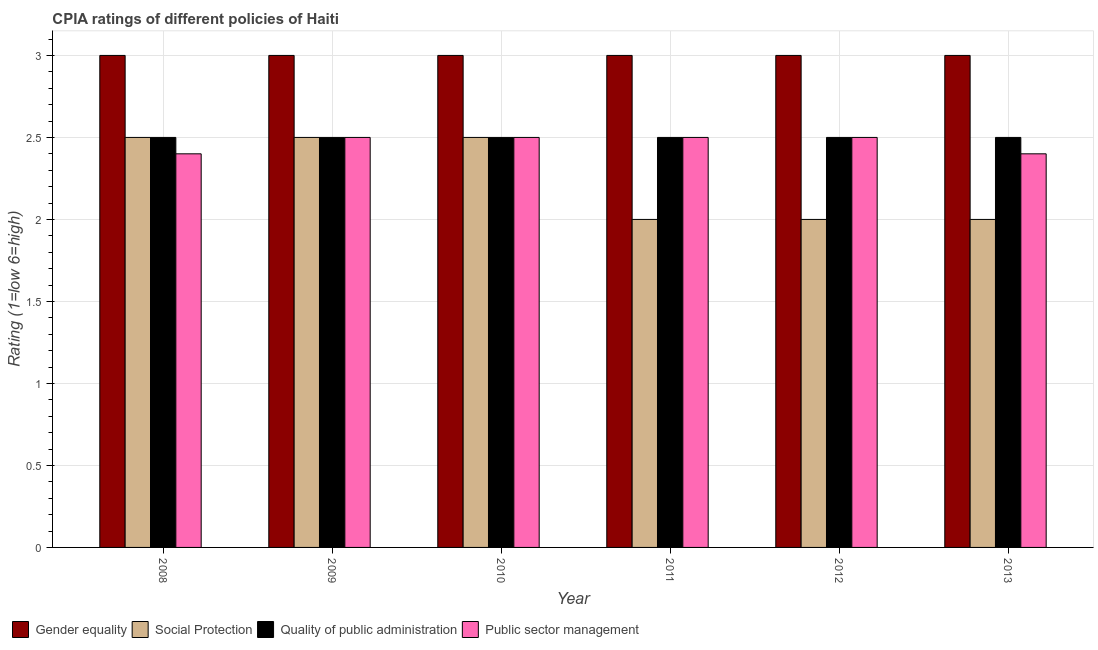Are the number of bars per tick equal to the number of legend labels?
Your response must be concise. Yes. How many bars are there on the 4th tick from the left?
Give a very brief answer. 4. How many bars are there on the 3rd tick from the right?
Offer a very short reply. 4. What is the label of the 5th group of bars from the left?
Make the answer very short. 2012. In how many cases, is the number of bars for a given year not equal to the number of legend labels?
Provide a short and direct response. 0. What is the cpia rating of gender equality in 2008?
Offer a terse response. 3. Across all years, what is the maximum cpia rating of gender equality?
Keep it short and to the point. 3. Across all years, what is the minimum cpia rating of public sector management?
Make the answer very short. 2.4. In which year was the cpia rating of public sector management maximum?
Offer a very short reply. 2009. In which year was the cpia rating of public sector management minimum?
Offer a terse response. 2008. What is the total cpia rating of gender equality in the graph?
Provide a succinct answer. 18. What is the difference between the cpia rating of public sector management in 2011 and that in 2013?
Offer a very short reply. 0.1. What is the average cpia rating of social protection per year?
Provide a short and direct response. 2.25. In the year 2008, what is the difference between the cpia rating of gender equality and cpia rating of social protection?
Offer a very short reply. 0. What is the difference between the highest and the second highest cpia rating of social protection?
Offer a very short reply. 0. What is the difference between the highest and the lowest cpia rating of gender equality?
Your answer should be very brief. 0. In how many years, is the cpia rating of gender equality greater than the average cpia rating of gender equality taken over all years?
Make the answer very short. 0. What does the 3rd bar from the left in 2011 represents?
Your answer should be compact. Quality of public administration. What does the 1st bar from the right in 2011 represents?
Offer a terse response. Public sector management. What is the difference between two consecutive major ticks on the Y-axis?
Keep it short and to the point. 0.5. Does the graph contain any zero values?
Your response must be concise. No. Does the graph contain grids?
Provide a short and direct response. Yes. Where does the legend appear in the graph?
Offer a terse response. Bottom left. How many legend labels are there?
Keep it short and to the point. 4. How are the legend labels stacked?
Make the answer very short. Horizontal. What is the title of the graph?
Your answer should be compact. CPIA ratings of different policies of Haiti. What is the Rating (1=low 6=high) of Gender equality in 2008?
Your answer should be very brief. 3. What is the Rating (1=low 6=high) in Social Protection in 2008?
Provide a succinct answer. 2.5. What is the Rating (1=low 6=high) in Gender equality in 2009?
Offer a terse response. 3. What is the Rating (1=low 6=high) of Gender equality in 2010?
Offer a terse response. 3. What is the Rating (1=low 6=high) of Social Protection in 2010?
Your response must be concise. 2.5. What is the Rating (1=low 6=high) of Quality of public administration in 2010?
Provide a short and direct response. 2.5. What is the Rating (1=low 6=high) of Social Protection in 2011?
Your answer should be very brief. 2. What is the Rating (1=low 6=high) of Public sector management in 2011?
Keep it short and to the point. 2.5. What is the Rating (1=low 6=high) of Gender equality in 2012?
Provide a short and direct response. 3. What is the Rating (1=low 6=high) of Quality of public administration in 2012?
Your answer should be very brief. 2.5. What is the Rating (1=low 6=high) of Public sector management in 2012?
Keep it short and to the point. 2.5. What is the Rating (1=low 6=high) of Gender equality in 2013?
Make the answer very short. 3. What is the Rating (1=low 6=high) in Social Protection in 2013?
Give a very brief answer. 2. What is the Rating (1=low 6=high) in Quality of public administration in 2013?
Provide a succinct answer. 2.5. What is the Rating (1=low 6=high) in Public sector management in 2013?
Provide a short and direct response. 2.4. Across all years, what is the maximum Rating (1=low 6=high) in Social Protection?
Give a very brief answer. 2.5. Across all years, what is the minimum Rating (1=low 6=high) in Social Protection?
Provide a succinct answer. 2. Across all years, what is the minimum Rating (1=low 6=high) of Quality of public administration?
Ensure brevity in your answer.  2.5. Across all years, what is the minimum Rating (1=low 6=high) in Public sector management?
Your response must be concise. 2.4. What is the total Rating (1=low 6=high) in Gender equality in the graph?
Your answer should be compact. 18. What is the total Rating (1=low 6=high) in Quality of public administration in the graph?
Give a very brief answer. 15. What is the difference between the Rating (1=low 6=high) in Gender equality in 2008 and that in 2009?
Keep it short and to the point. 0. What is the difference between the Rating (1=low 6=high) of Quality of public administration in 2008 and that in 2009?
Offer a terse response. 0. What is the difference between the Rating (1=low 6=high) of Public sector management in 2008 and that in 2009?
Provide a succinct answer. -0.1. What is the difference between the Rating (1=low 6=high) in Social Protection in 2008 and that in 2010?
Give a very brief answer. 0. What is the difference between the Rating (1=low 6=high) in Public sector management in 2008 and that in 2010?
Ensure brevity in your answer.  -0.1. What is the difference between the Rating (1=low 6=high) in Gender equality in 2008 and that in 2011?
Offer a terse response. 0. What is the difference between the Rating (1=low 6=high) in Quality of public administration in 2008 and that in 2011?
Give a very brief answer. 0. What is the difference between the Rating (1=low 6=high) of Public sector management in 2008 and that in 2011?
Make the answer very short. -0.1. What is the difference between the Rating (1=low 6=high) in Gender equality in 2008 and that in 2012?
Give a very brief answer. 0. What is the difference between the Rating (1=low 6=high) of Social Protection in 2008 and that in 2012?
Your answer should be compact. 0.5. What is the difference between the Rating (1=low 6=high) in Public sector management in 2008 and that in 2012?
Your answer should be very brief. -0.1. What is the difference between the Rating (1=low 6=high) in Social Protection in 2008 and that in 2013?
Offer a terse response. 0.5. What is the difference between the Rating (1=low 6=high) of Quality of public administration in 2008 and that in 2013?
Keep it short and to the point. 0. What is the difference between the Rating (1=low 6=high) in Public sector management in 2009 and that in 2010?
Provide a succinct answer. 0. What is the difference between the Rating (1=low 6=high) of Gender equality in 2009 and that in 2011?
Your answer should be compact. 0. What is the difference between the Rating (1=low 6=high) in Social Protection in 2009 and that in 2011?
Give a very brief answer. 0.5. What is the difference between the Rating (1=low 6=high) of Quality of public administration in 2009 and that in 2011?
Offer a terse response. 0. What is the difference between the Rating (1=low 6=high) of Public sector management in 2009 and that in 2011?
Keep it short and to the point. 0. What is the difference between the Rating (1=low 6=high) in Gender equality in 2009 and that in 2012?
Provide a succinct answer. 0. What is the difference between the Rating (1=low 6=high) of Social Protection in 2009 and that in 2012?
Your response must be concise. 0.5. What is the difference between the Rating (1=low 6=high) of Public sector management in 2009 and that in 2012?
Make the answer very short. 0. What is the difference between the Rating (1=low 6=high) of Social Protection in 2009 and that in 2013?
Provide a short and direct response. 0.5. What is the difference between the Rating (1=low 6=high) in Public sector management in 2009 and that in 2013?
Provide a succinct answer. 0.1. What is the difference between the Rating (1=low 6=high) in Gender equality in 2010 and that in 2011?
Provide a short and direct response. 0. What is the difference between the Rating (1=low 6=high) of Social Protection in 2010 and that in 2012?
Your answer should be very brief. 0.5. What is the difference between the Rating (1=low 6=high) of Quality of public administration in 2010 and that in 2012?
Keep it short and to the point. 0. What is the difference between the Rating (1=low 6=high) in Public sector management in 2010 and that in 2012?
Offer a very short reply. 0. What is the difference between the Rating (1=low 6=high) of Gender equality in 2010 and that in 2013?
Your answer should be very brief. 0. What is the difference between the Rating (1=low 6=high) of Social Protection in 2010 and that in 2013?
Your response must be concise. 0.5. What is the difference between the Rating (1=low 6=high) in Social Protection in 2011 and that in 2012?
Keep it short and to the point. 0. What is the difference between the Rating (1=low 6=high) of Quality of public administration in 2011 and that in 2012?
Keep it short and to the point. 0. What is the difference between the Rating (1=low 6=high) in Gender equality in 2011 and that in 2013?
Your answer should be compact. 0. What is the difference between the Rating (1=low 6=high) in Social Protection in 2011 and that in 2013?
Make the answer very short. 0. What is the difference between the Rating (1=low 6=high) in Public sector management in 2011 and that in 2013?
Give a very brief answer. 0.1. What is the difference between the Rating (1=low 6=high) of Social Protection in 2012 and that in 2013?
Your answer should be very brief. 0. What is the difference between the Rating (1=low 6=high) of Quality of public administration in 2012 and that in 2013?
Provide a short and direct response. 0. What is the difference between the Rating (1=low 6=high) of Gender equality in 2008 and the Rating (1=low 6=high) of Quality of public administration in 2009?
Your response must be concise. 0.5. What is the difference between the Rating (1=low 6=high) of Gender equality in 2008 and the Rating (1=low 6=high) of Social Protection in 2010?
Offer a very short reply. 0.5. What is the difference between the Rating (1=low 6=high) of Social Protection in 2008 and the Rating (1=low 6=high) of Quality of public administration in 2010?
Make the answer very short. 0. What is the difference between the Rating (1=low 6=high) in Social Protection in 2008 and the Rating (1=low 6=high) in Public sector management in 2011?
Make the answer very short. 0. What is the difference between the Rating (1=low 6=high) in Quality of public administration in 2008 and the Rating (1=low 6=high) in Public sector management in 2011?
Your answer should be compact. 0. What is the difference between the Rating (1=low 6=high) of Gender equality in 2008 and the Rating (1=low 6=high) of Public sector management in 2012?
Your answer should be very brief. 0.5. What is the difference between the Rating (1=low 6=high) in Social Protection in 2008 and the Rating (1=low 6=high) in Quality of public administration in 2012?
Ensure brevity in your answer.  0. What is the difference between the Rating (1=low 6=high) in Social Protection in 2008 and the Rating (1=low 6=high) in Public sector management in 2012?
Ensure brevity in your answer.  0. What is the difference between the Rating (1=low 6=high) of Quality of public administration in 2008 and the Rating (1=low 6=high) of Public sector management in 2012?
Your answer should be compact. 0. What is the difference between the Rating (1=low 6=high) of Gender equality in 2008 and the Rating (1=low 6=high) of Quality of public administration in 2013?
Keep it short and to the point. 0.5. What is the difference between the Rating (1=low 6=high) of Social Protection in 2008 and the Rating (1=low 6=high) of Quality of public administration in 2013?
Make the answer very short. 0. What is the difference between the Rating (1=low 6=high) in Social Protection in 2009 and the Rating (1=low 6=high) in Quality of public administration in 2010?
Make the answer very short. 0. What is the difference between the Rating (1=low 6=high) of Gender equality in 2009 and the Rating (1=low 6=high) of Social Protection in 2011?
Ensure brevity in your answer.  1. What is the difference between the Rating (1=low 6=high) in Gender equality in 2009 and the Rating (1=low 6=high) in Public sector management in 2011?
Provide a short and direct response. 0.5. What is the difference between the Rating (1=low 6=high) of Social Protection in 2009 and the Rating (1=low 6=high) of Quality of public administration in 2011?
Make the answer very short. 0. What is the difference between the Rating (1=low 6=high) of Social Protection in 2009 and the Rating (1=low 6=high) of Public sector management in 2011?
Make the answer very short. 0. What is the difference between the Rating (1=low 6=high) of Gender equality in 2009 and the Rating (1=low 6=high) of Social Protection in 2012?
Your answer should be very brief. 1. What is the difference between the Rating (1=low 6=high) of Social Protection in 2009 and the Rating (1=low 6=high) of Quality of public administration in 2012?
Your response must be concise. 0. What is the difference between the Rating (1=low 6=high) in Social Protection in 2009 and the Rating (1=low 6=high) in Public sector management in 2012?
Keep it short and to the point. 0. What is the difference between the Rating (1=low 6=high) in Quality of public administration in 2009 and the Rating (1=low 6=high) in Public sector management in 2012?
Keep it short and to the point. 0. What is the difference between the Rating (1=low 6=high) of Gender equality in 2009 and the Rating (1=low 6=high) of Social Protection in 2013?
Your answer should be compact. 1. What is the difference between the Rating (1=low 6=high) of Gender equality in 2009 and the Rating (1=low 6=high) of Quality of public administration in 2013?
Provide a succinct answer. 0.5. What is the difference between the Rating (1=low 6=high) in Gender equality in 2009 and the Rating (1=low 6=high) in Public sector management in 2013?
Your answer should be very brief. 0.6. What is the difference between the Rating (1=low 6=high) in Gender equality in 2010 and the Rating (1=low 6=high) in Quality of public administration in 2011?
Give a very brief answer. 0.5. What is the difference between the Rating (1=low 6=high) in Gender equality in 2010 and the Rating (1=low 6=high) in Social Protection in 2012?
Provide a short and direct response. 1. What is the difference between the Rating (1=low 6=high) of Gender equality in 2010 and the Rating (1=low 6=high) of Quality of public administration in 2012?
Offer a terse response. 0.5. What is the difference between the Rating (1=low 6=high) of Gender equality in 2010 and the Rating (1=low 6=high) of Public sector management in 2012?
Make the answer very short. 0.5. What is the difference between the Rating (1=low 6=high) of Social Protection in 2010 and the Rating (1=low 6=high) of Public sector management in 2012?
Give a very brief answer. 0. What is the difference between the Rating (1=low 6=high) in Quality of public administration in 2010 and the Rating (1=low 6=high) in Public sector management in 2012?
Your answer should be compact. 0. What is the difference between the Rating (1=low 6=high) of Gender equality in 2010 and the Rating (1=low 6=high) of Public sector management in 2013?
Your answer should be very brief. 0.6. What is the difference between the Rating (1=low 6=high) of Social Protection in 2010 and the Rating (1=low 6=high) of Public sector management in 2013?
Provide a short and direct response. 0.1. What is the difference between the Rating (1=low 6=high) in Quality of public administration in 2010 and the Rating (1=low 6=high) in Public sector management in 2013?
Your answer should be very brief. 0.1. What is the difference between the Rating (1=low 6=high) in Gender equality in 2011 and the Rating (1=low 6=high) in Public sector management in 2012?
Make the answer very short. 0.5. What is the difference between the Rating (1=low 6=high) of Social Protection in 2011 and the Rating (1=low 6=high) of Quality of public administration in 2012?
Your answer should be very brief. -0.5. What is the difference between the Rating (1=low 6=high) of Gender equality in 2011 and the Rating (1=low 6=high) of Social Protection in 2013?
Your answer should be very brief. 1. What is the difference between the Rating (1=low 6=high) of Gender equality in 2011 and the Rating (1=low 6=high) of Quality of public administration in 2013?
Give a very brief answer. 0.5. What is the difference between the Rating (1=low 6=high) of Gender equality in 2011 and the Rating (1=low 6=high) of Public sector management in 2013?
Provide a succinct answer. 0.6. What is the difference between the Rating (1=low 6=high) of Social Protection in 2011 and the Rating (1=low 6=high) of Quality of public administration in 2013?
Your response must be concise. -0.5. What is the difference between the Rating (1=low 6=high) of Social Protection in 2011 and the Rating (1=low 6=high) of Public sector management in 2013?
Your answer should be compact. -0.4. What is the difference between the Rating (1=low 6=high) in Quality of public administration in 2011 and the Rating (1=low 6=high) in Public sector management in 2013?
Ensure brevity in your answer.  0.1. What is the difference between the Rating (1=low 6=high) of Gender equality in 2012 and the Rating (1=low 6=high) of Public sector management in 2013?
Give a very brief answer. 0.6. What is the difference between the Rating (1=low 6=high) in Social Protection in 2012 and the Rating (1=low 6=high) in Quality of public administration in 2013?
Offer a very short reply. -0.5. What is the difference between the Rating (1=low 6=high) in Social Protection in 2012 and the Rating (1=low 6=high) in Public sector management in 2013?
Offer a terse response. -0.4. What is the average Rating (1=low 6=high) in Gender equality per year?
Keep it short and to the point. 3. What is the average Rating (1=low 6=high) of Social Protection per year?
Keep it short and to the point. 2.25. What is the average Rating (1=low 6=high) of Public sector management per year?
Your answer should be very brief. 2.47. In the year 2008, what is the difference between the Rating (1=low 6=high) in Gender equality and Rating (1=low 6=high) in Social Protection?
Keep it short and to the point. 0.5. In the year 2008, what is the difference between the Rating (1=low 6=high) of Gender equality and Rating (1=low 6=high) of Quality of public administration?
Ensure brevity in your answer.  0.5. In the year 2008, what is the difference between the Rating (1=low 6=high) in Gender equality and Rating (1=low 6=high) in Public sector management?
Your answer should be very brief. 0.6. In the year 2008, what is the difference between the Rating (1=low 6=high) in Quality of public administration and Rating (1=low 6=high) in Public sector management?
Provide a succinct answer. 0.1. In the year 2009, what is the difference between the Rating (1=low 6=high) of Gender equality and Rating (1=low 6=high) of Social Protection?
Your answer should be compact. 0.5. In the year 2009, what is the difference between the Rating (1=low 6=high) in Gender equality and Rating (1=low 6=high) in Public sector management?
Provide a succinct answer. 0.5. In the year 2009, what is the difference between the Rating (1=low 6=high) of Quality of public administration and Rating (1=low 6=high) of Public sector management?
Offer a terse response. 0. In the year 2010, what is the difference between the Rating (1=low 6=high) in Gender equality and Rating (1=low 6=high) in Public sector management?
Keep it short and to the point. 0.5. In the year 2010, what is the difference between the Rating (1=low 6=high) in Social Protection and Rating (1=low 6=high) in Public sector management?
Your answer should be compact. 0. In the year 2010, what is the difference between the Rating (1=low 6=high) in Quality of public administration and Rating (1=low 6=high) in Public sector management?
Give a very brief answer. 0. In the year 2011, what is the difference between the Rating (1=low 6=high) of Gender equality and Rating (1=low 6=high) of Social Protection?
Provide a short and direct response. 1. In the year 2011, what is the difference between the Rating (1=low 6=high) in Gender equality and Rating (1=low 6=high) in Quality of public administration?
Provide a succinct answer. 0.5. In the year 2011, what is the difference between the Rating (1=low 6=high) in Gender equality and Rating (1=low 6=high) in Public sector management?
Your response must be concise. 0.5. In the year 2011, what is the difference between the Rating (1=low 6=high) of Social Protection and Rating (1=low 6=high) of Quality of public administration?
Provide a succinct answer. -0.5. In the year 2011, what is the difference between the Rating (1=low 6=high) in Quality of public administration and Rating (1=low 6=high) in Public sector management?
Your answer should be compact. 0. In the year 2012, what is the difference between the Rating (1=low 6=high) in Gender equality and Rating (1=low 6=high) in Quality of public administration?
Keep it short and to the point. 0.5. In the year 2012, what is the difference between the Rating (1=low 6=high) in Social Protection and Rating (1=low 6=high) in Quality of public administration?
Make the answer very short. -0.5. In the year 2012, what is the difference between the Rating (1=low 6=high) of Quality of public administration and Rating (1=low 6=high) of Public sector management?
Your response must be concise. 0. In the year 2013, what is the difference between the Rating (1=low 6=high) in Social Protection and Rating (1=low 6=high) in Public sector management?
Ensure brevity in your answer.  -0.4. What is the ratio of the Rating (1=low 6=high) of Social Protection in 2008 to that in 2009?
Your response must be concise. 1. What is the ratio of the Rating (1=low 6=high) in Gender equality in 2008 to that in 2010?
Ensure brevity in your answer.  1. What is the ratio of the Rating (1=low 6=high) in Social Protection in 2008 to that in 2010?
Keep it short and to the point. 1. What is the ratio of the Rating (1=low 6=high) of Quality of public administration in 2008 to that in 2010?
Ensure brevity in your answer.  1. What is the ratio of the Rating (1=low 6=high) of Social Protection in 2008 to that in 2011?
Offer a terse response. 1.25. What is the ratio of the Rating (1=low 6=high) of Quality of public administration in 2008 to that in 2011?
Your response must be concise. 1. What is the ratio of the Rating (1=low 6=high) of Public sector management in 2008 to that in 2011?
Your answer should be compact. 0.96. What is the ratio of the Rating (1=low 6=high) of Gender equality in 2008 to that in 2012?
Your answer should be compact. 1. What is the ratio of the Rating (1=low 6=high) in Social Protection in 2008 to that in 2012?
Offer a terse response. 1.25. What is the ratio of the Rating (1=low 6=high) in Public sector management in 2008 to that in 2012?
Make the answer very short. 0.96. What is the ratio of the Rating (1=low 6=high) of Public sector management in 2008 to that in 2013?
Your response must be concise. 1. What is the ratio of the Rating (1=low 6=high) in Social Protection in 2009 to that in 2010?
Keep it short and to the point. 1. What is the ratio of the Rating (1=low 6=high) in Quality of public administration in 2009 to that in 2010?
Offer a terse response. 1. What is the ratio of the Rating (1=low 6=high) in Public sector management in 2009 to that in 2010?
Your response must be concise. 1. What is the ratio of the Rating (1=low 6=high) in Gender equality in 2009 to that in 2011?
Ensure brevity in your answer.  1. What is the ratio of the Rating (1=low 6=high) in Public sector management in 2009 to that in 2011?
Your answer should be compact. 1. What is the ratio of the Rating (1=low 6=high) of Gender equality in 2009 to that in 2012?
Make the answer very short. 1. What is the ratio of the Rating (1=low 6=high) in Public sector management in 2009 to that in 2012?
Keep it short and to the point. 1. What is the ratio of the Rating (1=low 6=high) in Gender equality in 2009 to that in 2013?
Your answer should be compact. 1. What is the ratio of the Rating (1=low 6=high) of Social Protection in 2009 to that in 2013?
Make the answer very short. 1.25. What is the ratio of the Rating (1=low 6=high) in Public sector management in 2009 to that in 2013?
Offer a terse response. 1.04. What is the ratio of the Rating (1=low 6=high) of Social Protection in 2010 to that in 2011?
Offer a very short reply. 1.25. What is the ratio of the Rating (1=low 6=high) in Quality of public administration in 2010 to that in 2011?
Keep it short and to the point. 1. What is the ratio of the Rating (1=low 6=high) in Social Protection in 2010 to that in 2012?
Your answer should be very brief. 1.25. What is the ratio of the Rating (1=low 6=high) in Quality of public administration in 2010 to that in 2012?
Your answer should be very brief. 1. What is the ratio of the Rating (1=low 6=high) of Social Protection in 2010 to that in 2013?
Your answer should be very brief. 1.25. What is the ratio of the Rating (1=low 6=high) of Quality of public administration in 2010 to that in 2013?
Ensure brevity in your answer.  1. What is the ratio of the Rating (1=low 6=high) of Public sector management in 2010 to that in 2013?
Make the answer very short. 1.04. What is the ratio of the Rating (1=low 6=high) of Social Protection in 2011 to that in 2013?
Provide a succinct answer. 1. What is the ratio of the Rating (1=low 6=high) of Quality of public administration in 2011 to that in 2013?
Your answer should be compact. 1. What is the ratio of the Rating (1=low 6=high) of Public sector management in 2011 to that in 2013?
Provide a succinct answer. 1.04. What is the ratio of the Rating (1=low 6=high) in Gender equality in 2012 to that in 2013?
Offer a terse response. 1. What is the ratio of the Rating (1=low 6=high) of Public sector management in 2012 to that in 2013?
Offer a terse response. 1.04. What is the difference between the highest and the lowest Rating (1=low 6=high) in Social Protection?
Provide a succinct answer. 0.5. What is the difference between the highest and the lowest Rating (1=low 6=high) of Quality of public administration?
Offer a very short reply. 0. What is the difference between the highest and the lowest Rating (1=low 6=high) of Public sector management?
Your response must be concise. 0.1. 